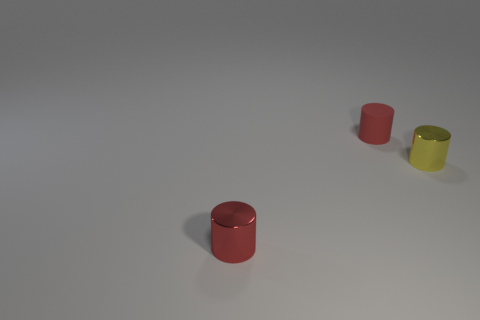Subtract all small metal cylinders. How many cylinders are left? 1 Add 1 large gray rubber blocks. How many objects exist? 4 Subtract 1 cylinders. How many cylinders are left? 2 Subtract all red cylinders. How many cylinders are left? 1 Subtract all gray cylinders. Subtract all yellow cubes. How many cylinders are left? 3 Subtract all yellow balls. How many purple cylinders are left? 0 Subtract all red rubber things. Subtract all blue shiny things. How many objects are left? 2 Add 1 tiny yellow metallic cylinders. How many tiny yellow metallic cylinders are left? 2 Add 2 red rubber cylinders. How many red rubber cylinders exist? 3 Subtract 0 red balls. How many objects are left? 3 